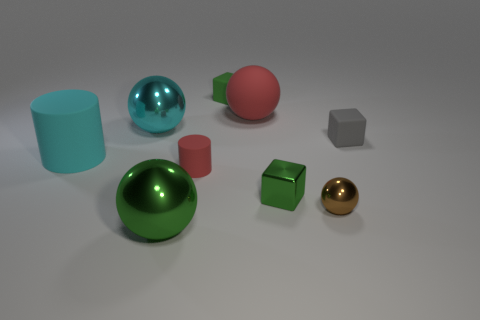There is a matte block that is in front of the big rubber sphere; is its color the same as the small metallic block?
Provide a succinct answer. No. What number of objects are on the left side of the cyan shiny sphere and right of the large cyan metallic ball?
Your answer should be very brief. 0. There is another matte thing that is the same shape as the large green object; what size is it?
Your answer should be very brief. Large. There is a green object that is in front of the small green metal object that is to the right of the big cyan matte thing; how many gray objects are in front of it?
Offer a terse response. 0. There is a big metal thing behind the tiny green metal cube that is in front of the large red ball; what is its color?
Your answer should be compact. Cyan. What number of other things are made of the same material as the gray thing?
Keep it short and to the point. 4. There is a cylinder that is left of the tiny matte cylinder; how many big matte cylinders are on the right side of it?
Ensure brevity in your answer.  0. Are there any other things that are the same shape as the small brown metal object?
Your response must be concise. Yes. Does the matte cylinder right of the large green object have the same color as the small block in front of the large cyan matte cylinder?
Your answer should be very brief. No. Is the number of small green matte things less than the number of blue metal balls?
Your response must be concise. No. 